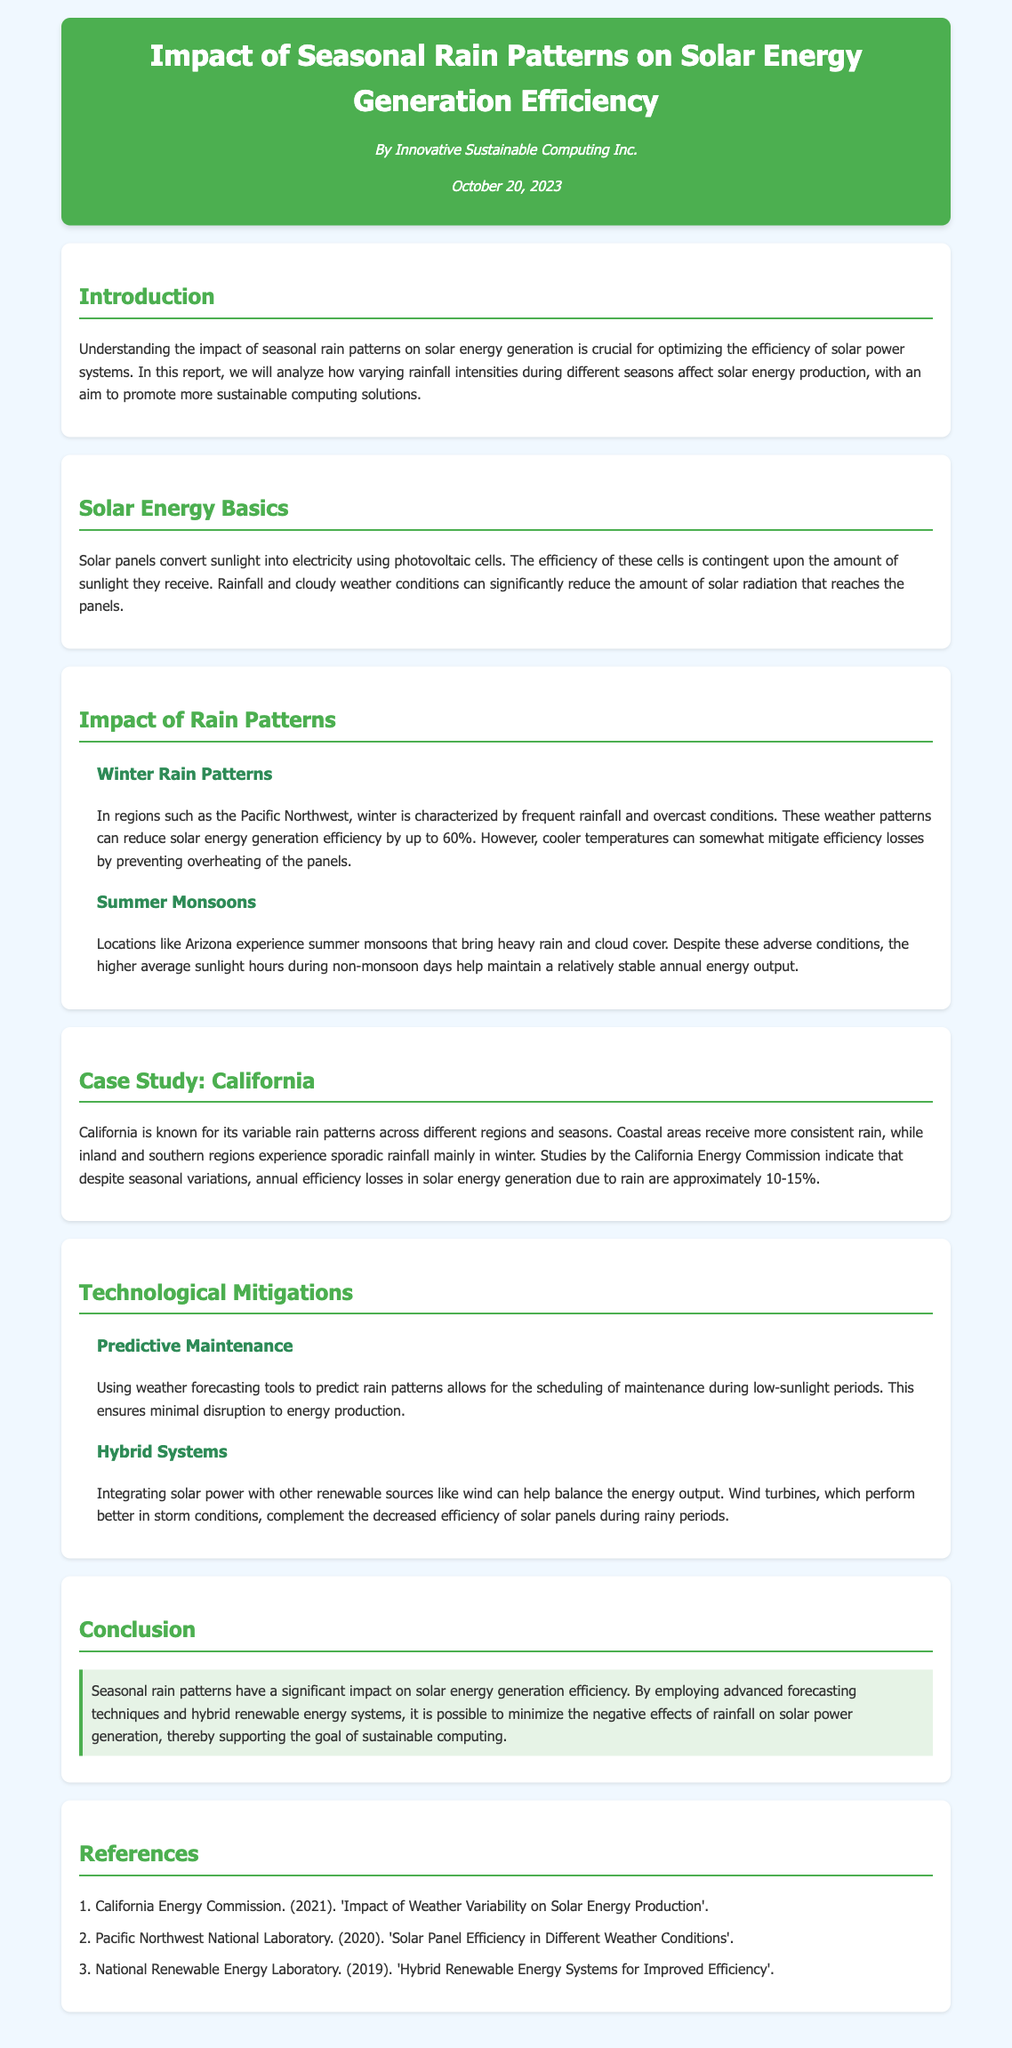What is the title of the document? The title is prominently displayed at the top of the document.
Answer: Impact of Seasonal Rain Patterns on Solar Energy Generation Efficiency Who authored the report? The author is mentioned in the header of the document.
Answer: Innovative Sustainable Computing Inc When was the report published? The publication date is listed in the header right below the author.
Answer: October 20, 2023 What percentage can winter rain patterns reduce solar energy generation efficiency by? The impact of winter rain patterns on efficiency is described specifically in the relevant section.
Answer: up to 60% What is the annual efficiency loss in solar energy generation due to rain in California? The case study section provides specific information regarding California's solar energy efficiency losses.
Answer: approximately 10-15% Which renewable energy source is suggested to integrate with solar power? The technological mitigations section discusses hybrid systems and other renewable sources.
Answer: wind What is one technological mitigation mentioned in the report? The section on technological mitigations lists various strategies, focusing primarily on maintenance and system integration.
Answer: Predictive Maintenance What color is the report's header background? The header's background color is described in the style rules at the beginning of the code.
Answer: #4CAF50 